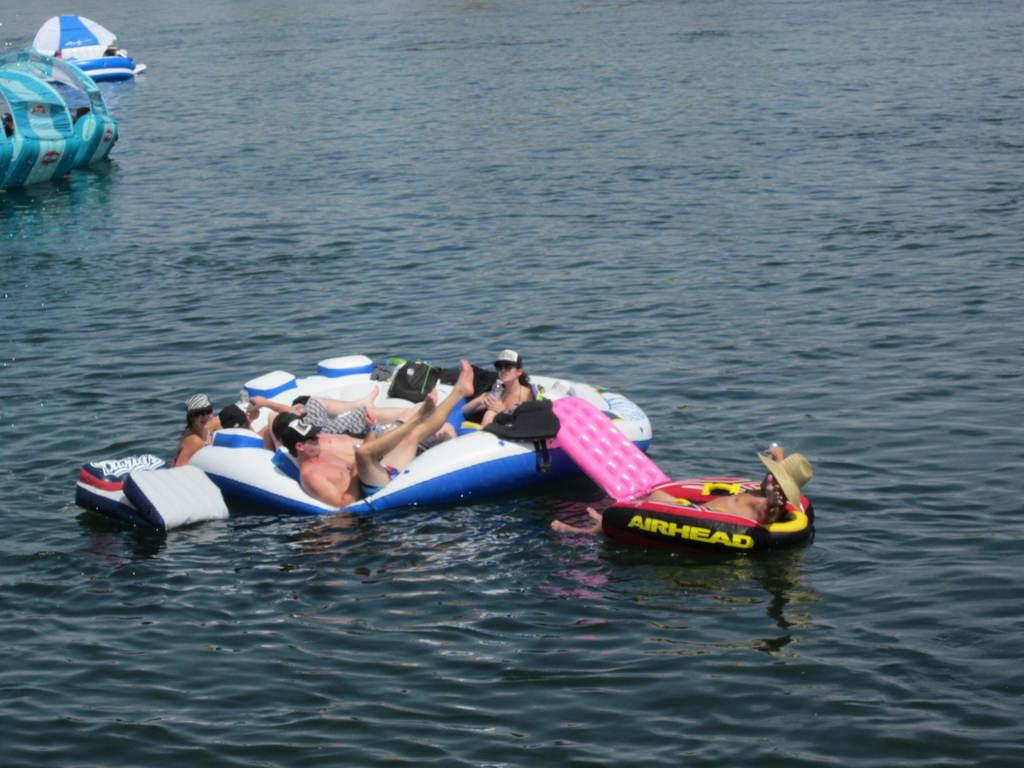What are the people in the image doing? The people in the image are in an inflatable boat. What can be seen in the background of the image? There is water visible in the background of the image. How many toes are visible on the people in the image? There is no information about the people's toes in the image, so it cannot be determined. 